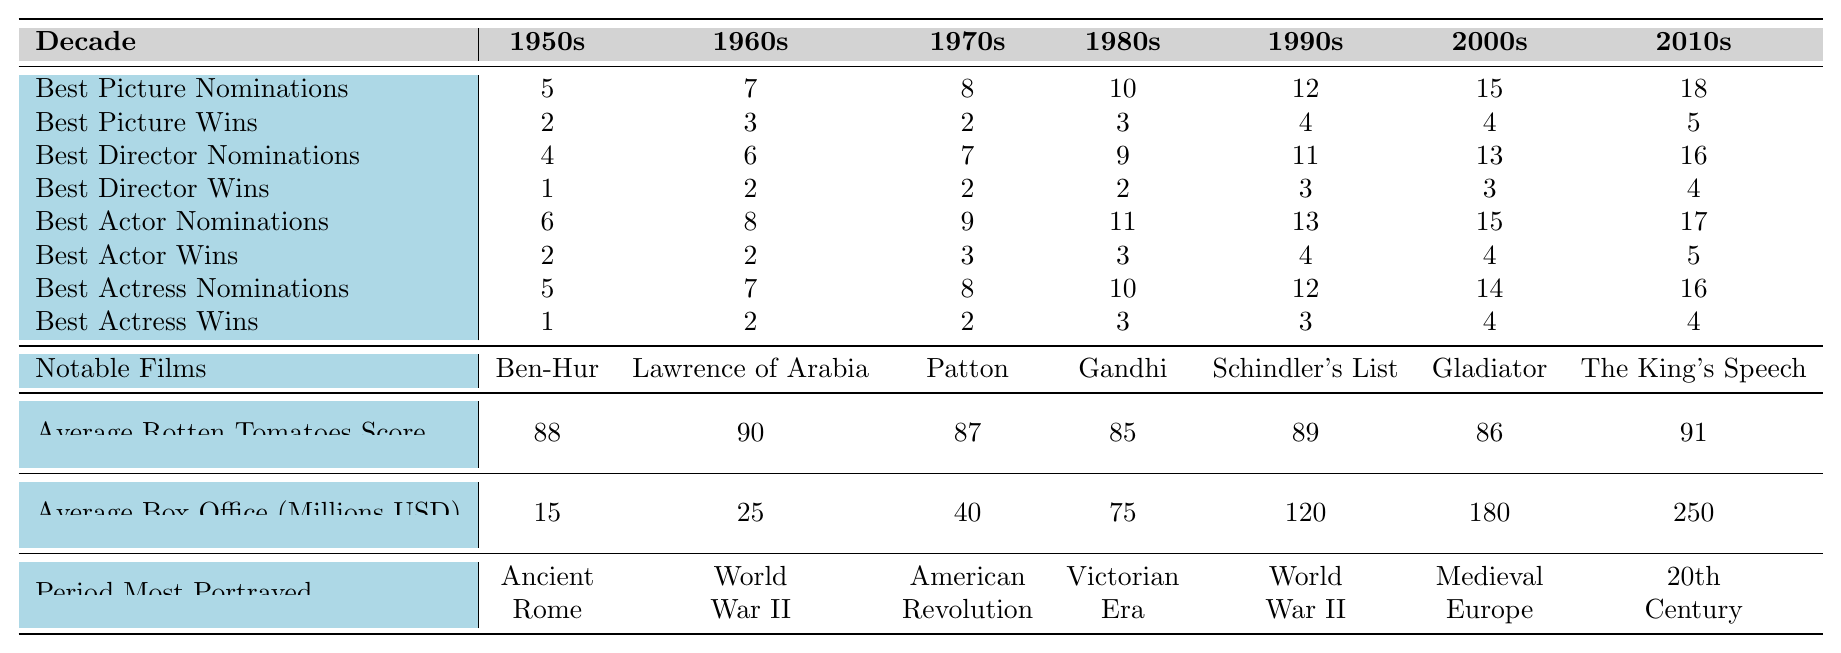What decade saw the highest number of Best Picture nominations for historical dramas? Looking at the "Best Picture Nominations" row, the highest number is 18, which is in the 2010s decade.
Answer: 2010s How many Best Actress wins did historical dramas achieve in the 1980s? In the "Best Actress Wins" row for the 1980s, the value is 3.
Answer: 3 Which period was most portrayed in the 2000s? In the "Period Most Portrayed" row for the 2000s, it shows "Medieval Europe" as the most portrayed period.
Answer: Medieval Europe Did the number of Best Director nominations increase from the 1950s to the 2010s? Comparing the "Best Director Nominations", 1950s had 4, and 2010s had 16, which means there is an increase.
Answer: Yes What was the average box office gross for historical dramas in the 1990s? According to the "Average Box Office (Millions USD)" section for the 1990s, the value is 120 million USD.
Answer: 120 million USD How many more Best Picture wins were there in the 2010s than in the 1990s? In the 2010s, there were 5 Best Picture wins, and in the 1990s, there were 4. Calculating the difference: 5 - 4 = 1.
Answer: 1 Which decade had the lowest average Rotten Tomatoes score for historical dramas? The "Average Rotten Tomatoes Score" shows that the 1980s had the lowest score of 85.
Answer: 1980s What is the total number of Best Actor nominations across all decades? Adding the values from "Best Actor Nominations": 6 + 8 + 9 + 11 + 13 + 15 + 17 = 79.
Answer: 79 Is the average Rotten Tomatoes score for historical dramas higher in the 1960s or the 2000s? The scores are 90 for the 1960s and 86 for the 2000s. Since 90 > 86, the 1960s has a higher score.
Answer: 1960s In which decade did historical dramas have the most notable films listed? The table lists notable films from each decade, with the last notable film listed being "The King's Speech" for the 2010s, indicating the 2010s had the most notable films.
Answer: 2010s 